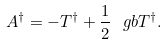Convert formula to latex. <formula><loc_0><loc_0><loc_500><loc_500>A ^ { \dag } = - T ^ { \dag } + \frac { 1 } { 2 } { \ g b } T ^ { \dag } .</formula> 